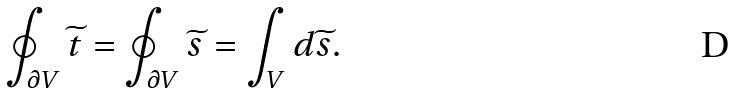Convert formula to latex. <formula><loc_0><loc_0><loc_500><loc_500>\oint _ { \partial V } \widetilde { t } = \oint _ { \partial V } \widetilde { s } = \int _ { V } { d } \widetilde { s } .</formula> 